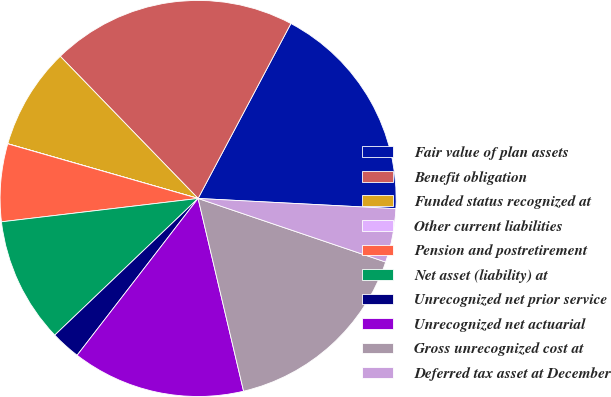<chart> <loc_0><loc_0><loc_500><loc_500><pie_chart><fcel>Fair value of plan assets<fcel>Benefit obligation<fcel>Funded status recognized at<fcel>Other current liabilities<fcel>Pension and postretirement<fcel>Net asset (liability) at<fcel>Unrecognized net prior service<fcel>Unrecognized net actuarial<fcel>Gross unrecognized cost at<fcel>Deferred tax asset at December<nl><fcel>18.06%<fcel>20.02%<fcel>8.29%<fcel>0.01%<fcel>6.33%<fcel>10.24%<fcel>2.42%<fcel>14.15%<fcel>16.11%<fcel>4.38%<nl></chart> 